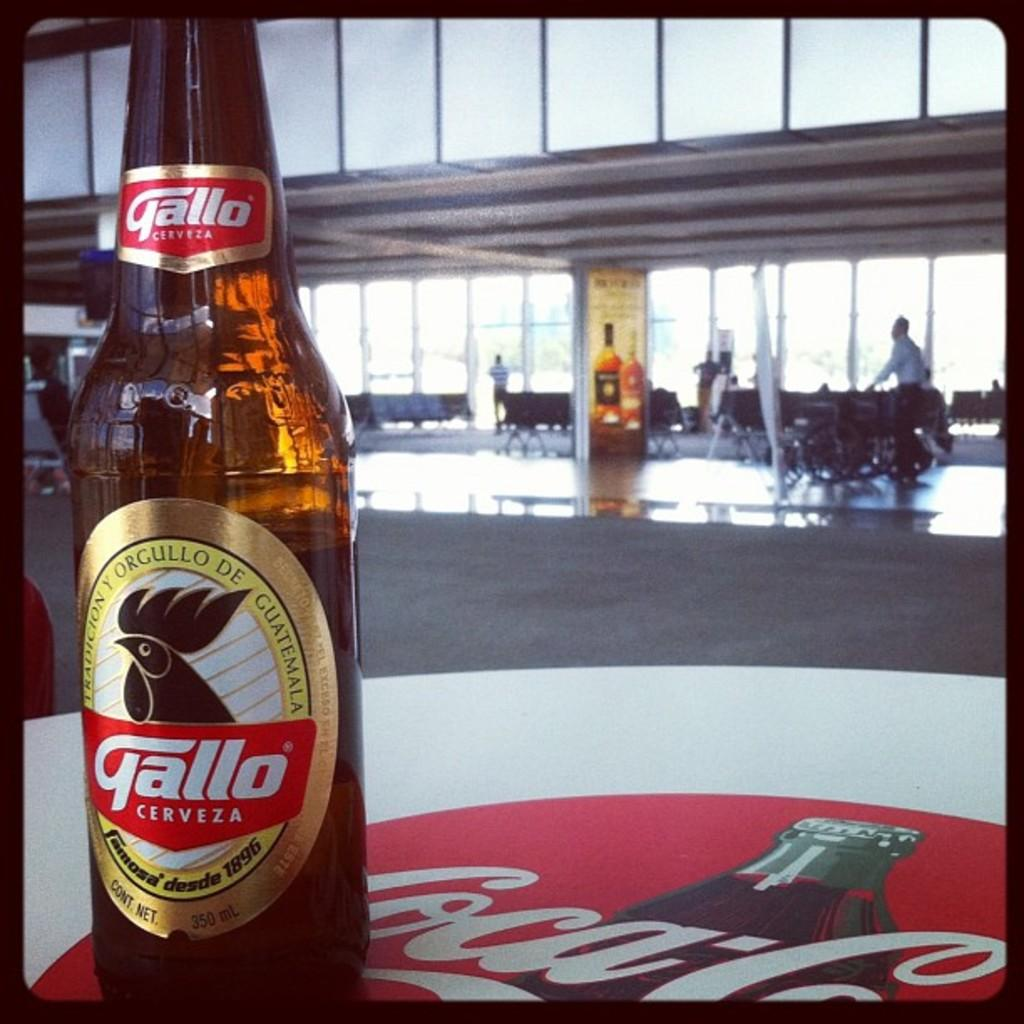<image>
Offer a succinct explanation of the picture presented. A bottle of Gallo Cerveza sits on a table brande by Coka Cola 